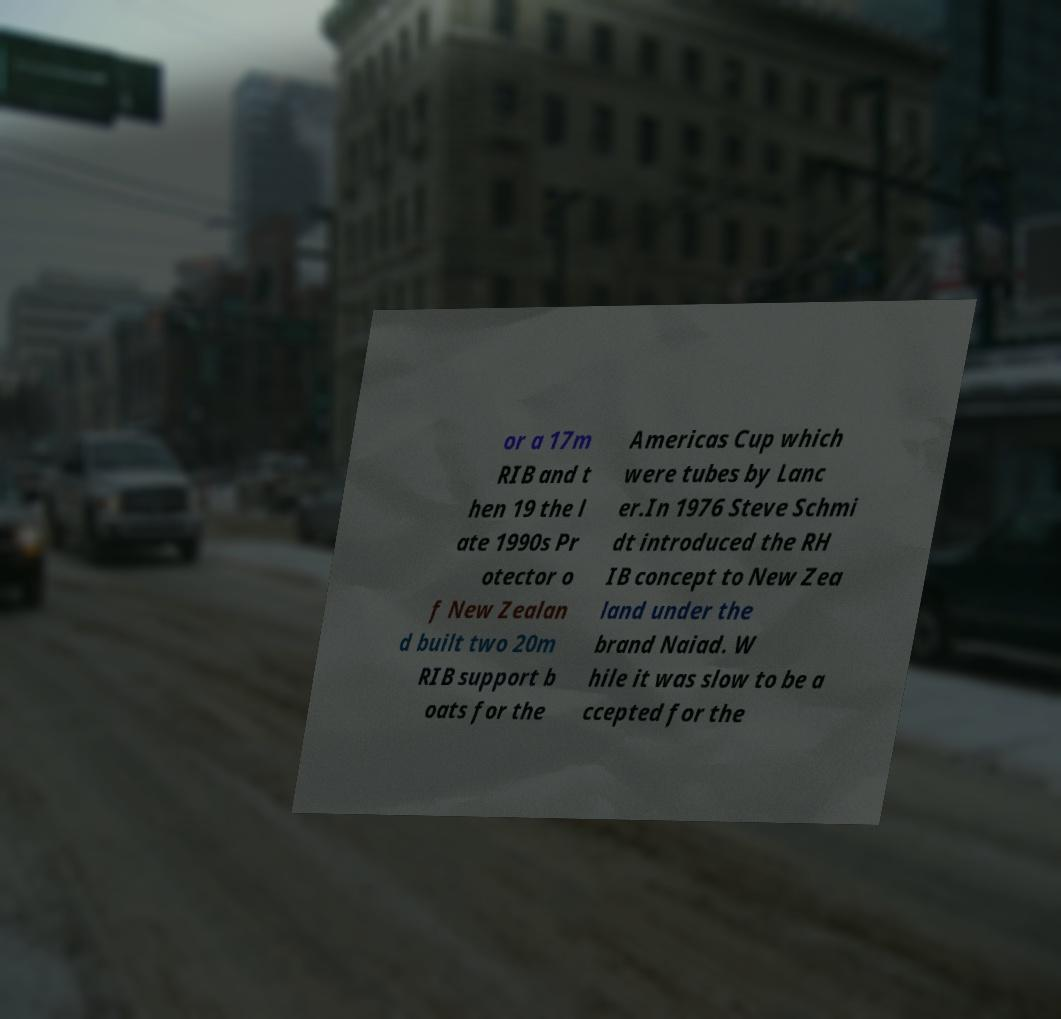Can you read and provide the text displayed in the image?This photo seems to have some interesting text. Can you extract and type it out for me? or a 17m RIB and t hen 19 the l ate 1990s Pr otector o f New Zealan d built two 20m RIB support b oats for the Americas Cup which were tubes by Lanc er.In 1976 Steve Schmi dt introduced the RH IB concept to New Zea land under the brand Naiad. W hile it was slow to be a ccepted for the 